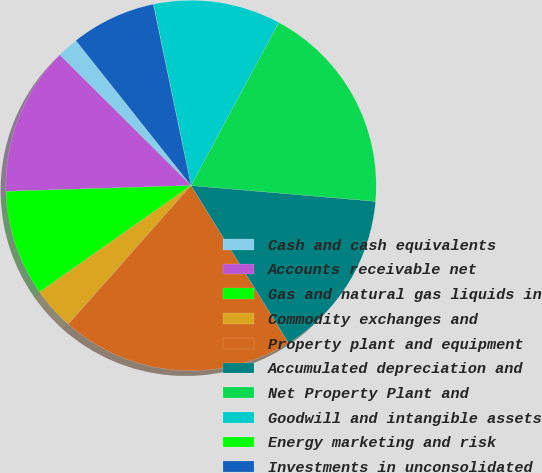<chart> <loc_0><loc_0><loc_500><loc_500><pie_chart><fcel>Cash and cash equivalents<fcel>Accounts receivable net<fcel>Gas and natural gas liquids in<fcel>Commodity exchanges and<fcel>Property plant and equipment<fcel>Accumulated depreciation and<fcel>Net Property Plant and<fcel>Goodwill and intangible assets<fcel>Energy marketing and risk<fcel>Investments in unconsolidated<nl><fcel>1.86%<fcel>12.96%<fcel>9.26%<fcel>3.71%<fcel>20.36%<fcel>14.81%<fcel>18.51%<fcel>11.11%<fcel>0.01%<fcel>7.41%<nl></chart> 